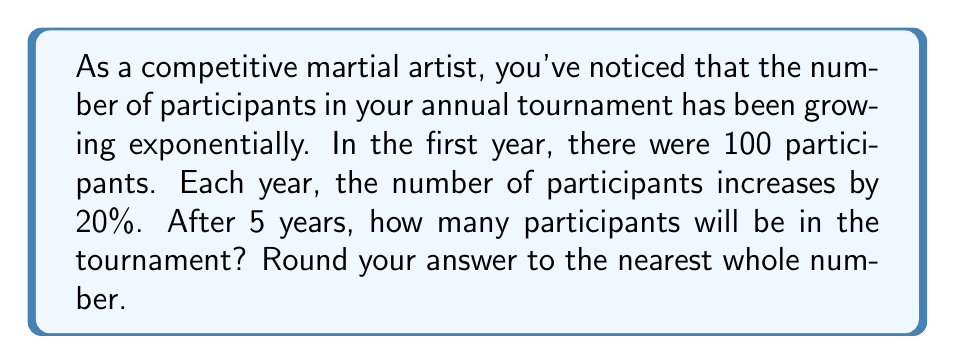Can you solve this math problem? Let's approach this step-by-step:

1) We start with 100 participants in the first year.

2) Each year, the number increases by 20%, which means it's multiplied by 1.20 (or 120%).

3) We need to calculate this growth over 5 years.

4) The formula for exponential growth is:

   $$A = P(1 + r)^n$$

   Where:
   $A$ = Final amount
   $P$ = Initial principal balance
   $r$ = Annual growth rate (in decimal form)
   $n$ = Number of years

5) Plugging in our values:
   $P = 100$ (initial participants)
   $r = 0.20$ (20% growth rate)
   $n = 5$ (years)

6) Let's calculate:

   $$A = 100(1 + 0.20)^5$$
   $$A = 100(1.20)^5$$
   $$A = 100(2.4883)$$
   $$A = 248.83$$

7) Rounding to the nearest whole number: 249
Answer: 249 participants 